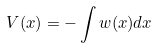Convert formula to latex. <formula><loc_0><loc_0><loc_500><loc_500>V ( x ) = - \int w ( x ) d x</formula> 